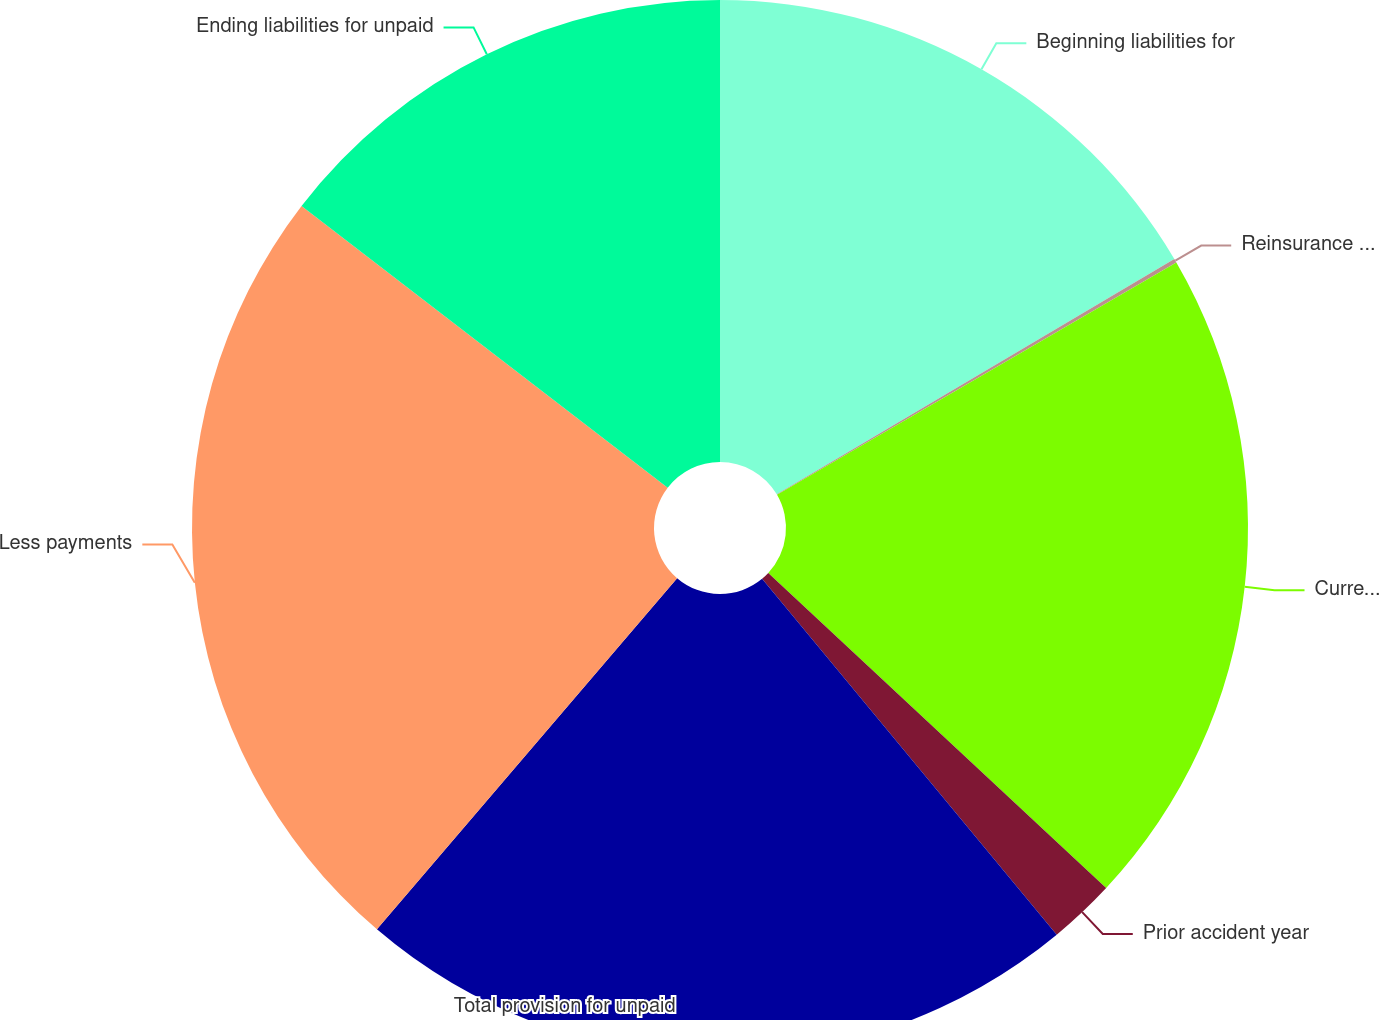Convert chart. <chart><loc_0><loc_0><loc_500><loc_500><pie_chart><fcel>Beginning liabilities for<fcel>Reinsurance and other<fcel>Current accident year before<fcel>Prior accident year<fcel>Total provision for unpaid<fcel>Less payments<fcel>Ending liabilities for unpaid<nl><fcel>16.49%<fcel>0.12%<fcel>20.33%<fcel>2.05%<fcel>22.26%<fcel>24.18%<fcel>14.56%<nl></chart> 